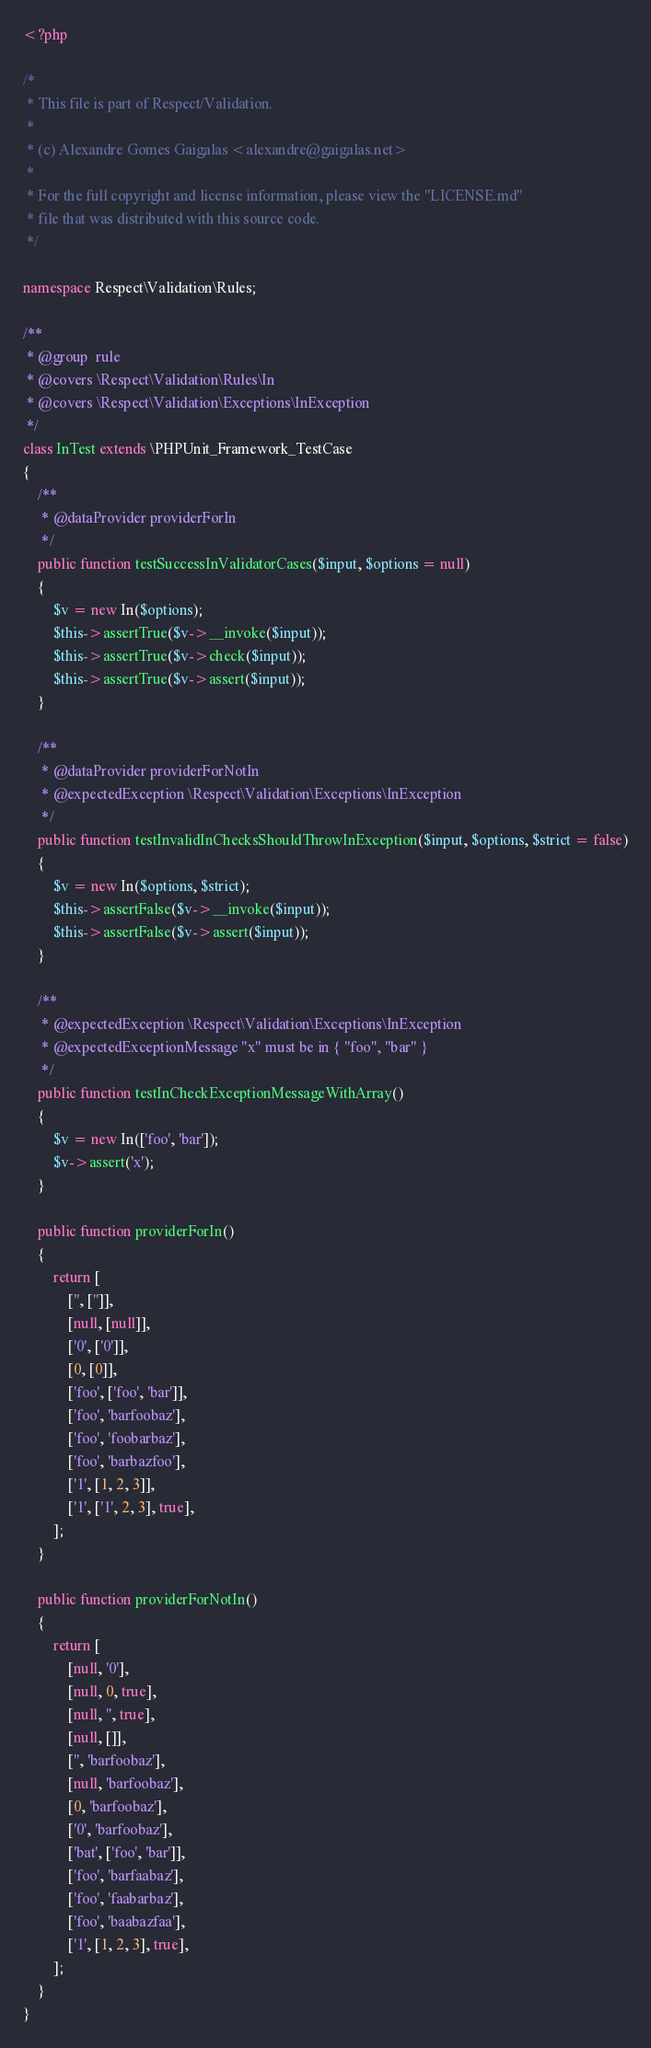Convert code to text. <code><loc_0><loc_0><loc_500><loc_500><_PHP_><?php

/*
 * This file is part of Respect/Validation.
 *
 * (c) Alexandre Gomes Gaigalas <alexandre@gaigalas.net>
 *
 * For the full copyright and license information, please view the "LICENSE.md"
 * file that was distributed with this source code.
 */

namespace Respect\Validation\Rules;

/**
 * @group  rule
 * @covers \Respect\Validation\Rules\In
 * @covers \Respect\Validation\Exceptions\InException
 */
class InTest extends \PHPUnit_Framework_TestCase
{
    /**
     * @dataProvider providerForIn
     */
    public function testSuccessInValidatorCases($input, $options = null)
    {
        $v = new In($options);
        $this->assertTrue($v->__invoke($input));
        $this->assertTrue($v->check($input));
        $this->assertTrue($v->assert($input));
    }

    /**
     * @dataProvider providerForNotIn
     * @expectedException \Respect\Validation\Exceptions\InException
     */
    public function testInvalidInChecksShouldThrowInException($input, $options, $strict = false)
    {
        $v = new In($options, $strict);
        $this->assertFalse($v->__invoke($input));
        $this->assertFalse($v->assert($input));
    }

    /**
     * @expectedException \Respect\Validation\Exceptions\InException
     * @expectedExceptionMessage "x" must be in { "foo", "bar" }
     */
    public function testInCheckExceptionMessageWithArray()
    {
        $v = new In(['foo', 'bar']);
        $v->assert('x');
    }

    public function providerForIn()
    {
        return [
            ['', ['']],
            [null, [null]],
            ['0', ['0']],
            [0, [0]],
            ['foo', ['foo', 'bar']],
            ['foo', 'barfoobaz'],
            ['foo', 'foobarbaz'],
            ['foo', 'barbazfoo'],
            ['1', [1, 2, 3]],
            ['1', ['1', 2, 3], true],
        ];
    }

    public function providerForNotIn()
    {
        return [
            [null, '0'],
            [null, 0, true],
            [null, '', true],
            [null, []],
            ['', 'barfoobaz'],
            [null, 'barfoobaz'],
            [0, 'barfoobaz'],
            ['0', 'barfoobaz'],
            ['bat', ['foo', 'bar']],
            ['foo', 'barfaabaz'],
            ['foo', 'faabarbaz'],
            ['foo', 'baabazfaa'],
            ['1', [1, 2, 3], true],
        ];
    }
}
</code> 